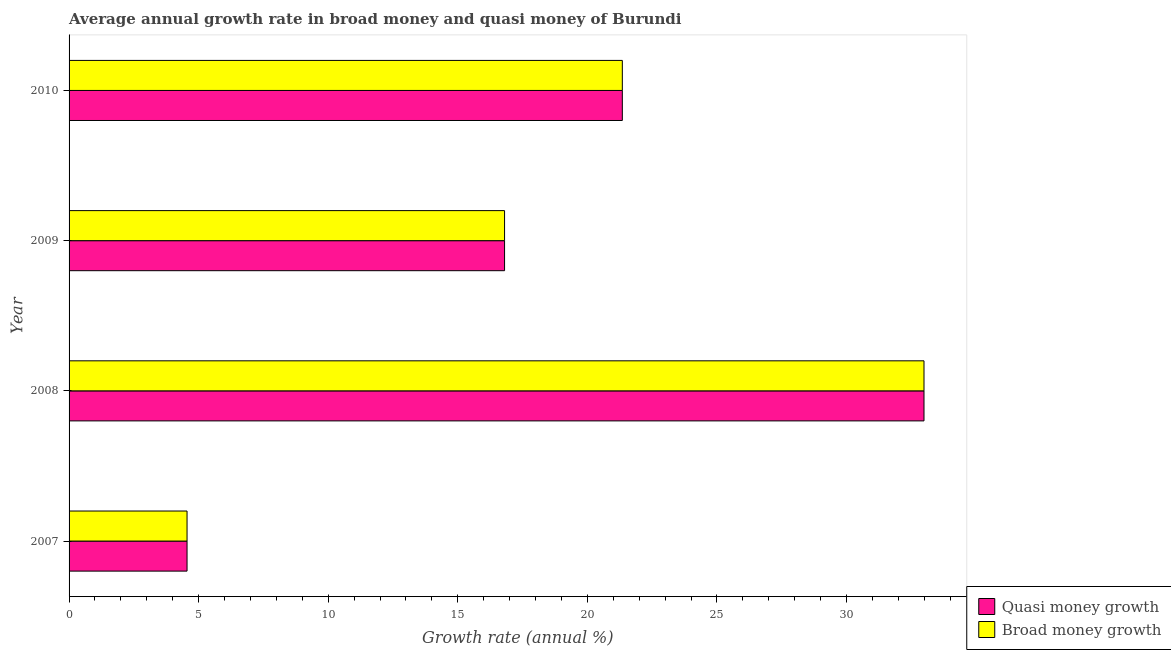How many different coloured bars are there?
Your answer should be very brief. 2. How many groups of bars are there?
Make the answer very short. 4. Are the number of bars per tick equal to the number of legend labels?
Your response must be concise. Yes. Are the number of bars on each tick of the Y-axis equal?
Your answer should be very brief. Yes. How many bars are there on the 4th tick from the top?
Ensure brevity in your answer.  2. How many bars are there on the 4th tick from the bottom?
Offer a very short reply. 2. What is the label of the 4th group of bars from the top?
Make the answer very short. 2007. What is the annual growth rate in broad money in 2008?
Ensure brevity in your answer.  32.99. Across all years, what is the maximum annual growth rate in broad money?
Give a very brief answer. 32.99. Across all years, what is the minimum annual growth rate in broad money?
Your response must be concise. 4.55. In which year was the annual growth rate in broad money maximum?
Your answer should be very brief. 2008. What is the total annual growth rate in broad money in the graph?
Offer a terse response. 75.7. What is the difference between the annual growth rate in quasi money in 2007 and that in 2008?
Ensure brevity in your answer.  -28.44. What is the difference between the annual growth rate in quasi money in 2009 and the annual growth rate in broad money in 2010?
Offer a very short reply. -4.54. What is the average annual growth rate in quasi money per year?
Provide a short and direct response. 18.93. In the year 2007, what is the difference between the annual growth rate in quasi money and annual growth rate in broad money?
Your answer should be compact. 0. What is the ratio of the annual growth rate in broad money in 2008 to that in 2009?
Provide a succinct answer. 1.96. Is the difference between the annual growth rate in quasi money in 2009 and 2010 greater than the difference between the annual growth rate in broad money in 2009 and 2010?
Make the answer very short. No. What is the difference between the highest and the second highest annual growth rate in quasi money?
Ensure brevity in your answer.  11.64. What is the difference between the highest and the lowest annual growth rate in quasi money?
Ensure brevity in your answer.  28.44. In how many years, is the annual growth rate in broad money greater than the average annual growth rate in broad money taken over all years?
Give a very brief answer. 2. Is the sum of the annual growth rate in quasi money in 2007 and 2010 greater than the maximum annual growth rate in broad money across all years?
Provide a short and direct response. No. What does the 1st bar from the top in 2007 represents?
Offer a terse response. Broad money growth. What does the 2nd bar from the bottom in 2009 represents?
Keep it short and to the point. Broad money growth. How many bars are there?
Your answer should be compact. 8. How many years are there in the graph?
Your answer should be compact. 4. Does the graph contain any zero values?
Your response must be concise. No. How many legend labels are there?
Your response must be concise. 2. How are the legend labels stacked?
Provide a short and direct response. Vertical. What is the title of the graph?
Make the answer very short. Average annual growth rate in broad money and quasi money of Burundi. Does "Primary education" appear as one of the legend labels in the graph?
Give a very brief answer. No. What is the label or title of the X-axis?
Your answer should be very brief. Growth rate (annual %). What is the label or title of the Y-axis?
Ensure brevity in your answer.  Year. What is the Growth rate (annual %) of Quasi money growth in 2007?
Your answer should be compact. 4.55. What is the Growth rate (annual %) in Broad money growth in 2007?
Give a very brief answer. 4.55. What is the Growth rate (annual %) in Quasi money growth in 2008?
Give a very brief answer. 32.99. What is the Growth rate (annual %) of Broad money growth in 2008?
Your response must be concise. 32.99. What is the Growth rate (annual %) of Quasi money growth in 2009?
Keep it short and to the point. 16.81. What is the Growth rate (annual %) of Broad money growth in 2009?
Provide a succinct answer. 16.81. What is the Growth rate (annual %) of Quasi money growth in 2010?
Provide a succinct answer. 21.35. What is the Growth rate (annual %) of Broad money growth in 2010?
Ensure brevity in your answer.  21.35. Across all years, what is the maximum Growth rate (annual %) of Quasi money growth?
Ensure brevity in your answer.  32.99. Across all years, what is the maximum Growth rate (annual %) in Broad money growth?
Your response must be concise. 32.99. Across all years, what is the minimum Growth rate (annual %) in Quasi money growth?
Give a very brief answer. 4.55. Across all years, what is the minimum Growth rate (annual %) in Broad money growth?
Keep it short and to the point. 4.55. What is the total Growth rate (annual %) of Quasi money growth in the graph?
Give a very brief answer. 75.7. What is the total Growth rate (annual %) in Broad money growth in the graph?
Offer a very short reply. 75.7. What is the difference between the Growth rate (annual %) of Quasi money growth in 2007 and that in 2008?
Make the answer very short. -28.44. What is the difference between the Growth rate (annual %) of Broad money growth in 2007 and that in 2008?
Make the answer very short. -28.44. What is the difference between the Growth rate (annual %) in Quasi money growth in 2007 and that in 2009?
Offer a very short reply. -12.25. What is the difference between the Growth rate (annual %) in Broad money growth in 2007 and that in 2009?
Your response must be concise. -12.25. What is the difference between the Growth rate (annual %) of Quasi money growth in 2007 and that in 2010?
Provide a succinct answer. -16.8. What is the difference between the Growth rate (annual %) in Broad money growth in 2007 and that in 2010?
Your answer should be very brief. -16.8. What is the difference between the Growth rate (annual %) in Quasi money growth in 2008 and that in 2009?
Provide a short and direct response. 16.19. What is the difference between the Growth rate (annual %) of Broad money growth in 2008 and that in 2009?
Offer a very short reply. 16.19. What is the difference between the Growth rate (annual %) of Quasi money growth in 2008 and that in 2010?
Your response must be concise. 11.64. What is the difference between the Growth rate (annual %) in Broad money growth in 2008 and that in 2010?
Make the answer very short. 11.64. What is the difference between the Growth rate (annual %) in Quasi money growth in 2009 and that in 2010?
Ensure brevity in your answer.  -4.54. What is the difference between the Growth rate (annual %) in Broad money growth in 2009 and that in 2010?
Your answer should be compact. -4.54. What is the difference between the Growth rate (annual %) of Quasi money growth in 2007 and the Growth rate (annual %) of Broad money growth in 2008?
Your response must be concise. -28.44. What is the difference between the Growth rate (annual %) in Quasi money growth in 2007 and the Growth rate (annual %) in Broad money growth in 2009?
Your answer should be compact. -12.25. What is the difference between the Growth rate (annual %) of Quasi money growth in 2007 and the Growth rate (annual %) of Broad money growth in 2010?
Your answer should be compact. -16.8. What is the difference between the Growth rate (annual %) of Quasi money growth in 2008 and the Growth rate (annual %) of Broad money growth in 2009?
Offer a very short reply. 16.19. What is the difference between the Growth rate (annual %) in Quasi money growth in 2008 and the Growth rate (annual %) in Broad money growth in 2010?
Provide a short and direct response. 11.64. What is the difference between the Growth rate (annual %) of Quasi money growth in 2009 and the Growth rate (annual %) of Broad money growth in 2010?
Offer a terse response. -4.54. What is the average Growth rate (annual %) in Quasi money growth per year?
Give a very brief answer. 18.92. What is the average Growth rate (annual %) in Broad money growth per year?
Provide a short and direct response. 18.92. In the year 2007, what is the difference between the Growth rate (annual %) of Quasi money growth and Growth rate (annual %) of Broad money growth?
Give a very brief answer. 0. In the year 2008, what is the difference between the Growth rate (annual %) of Quasi money growth and Growth rate (annual %) of Broad money growth?
Provide a short and direct response. 0. In the year 2009, what is the difference between the Growth rate (annual %) of Quasi money growth and Growth rate (annual %) of Broad money growth?
Ensure brevity in your answer.  0. What is the ratio of the Growth rate (annual %) of Quasi money growth in 2007 to that in 2008?
Give a very brief answer. 0.14. What is the ratio of the Growth rate (annual %) of Broad money growth in 2007 to that in 2008?
Keep it short and to the point. 0.14. What is the ratio of the Growth rate (annual %) of Quasi money growth in 2007 to that in 2009?
Ensure brevity in your answer.  0.27. What is the ratio of the Growth rate (annual %) of Broad money growth in 2007 to that in 2009?
Offer a terse response. 0.27. What is the ratio of the Growth rate (annual %) in Quasi money growth in 2007 to that in 2010?
Provide a succinct answer. 0.21. What is the ratio of the Growth rate (annual %) of Broad money growth in 2007 to that in 2010?
Make the answer very short. 0.21. What is the ratio of the Growth rate (annual %) in Quasi money growth in 2008 to that in 2009?
Give a very brief answer. 1.96. What is the ratio of the Growth rate (annual %) of Broad money growth in 2008 to that in 2009?
Your answer should be compact. 1.96. What is the ratio of the Growth rate (annual %) of Quasi money growth in 2008 to that in 2010?
Offer a terse response. 1.55. What is the ratio of the Growth rate (annual %) in Broad money growth in 2008 to that in 2010?
Your answer should be very brief. 1.55. What is the ratio of the Growth rate (annual %) of Quasi money growth in 2009 to that in 2010?
Provide a short and direct response. 0.79. What is the ratio of the Growth rate (annual %) in Broad money growth in 2009 to that in 2010?
Your answer should be compact. 0.79. What is the difference between the highest and the second highest Growth rate (annual %) in Quasi money growth?
Your response must be concise. 11.64. What is the difference between the highest and the second highest Growth rate (annual %) in Broad money growth?
Your answer should be compact. 11.64. What is the difference between the highest and the lowest Growth rate (annual %) of Quasi money growth?
Make the answer very short. 28.44. What is the difference between the highest and the lowest Growth rate (annual %) of Broad money growth?
Your answer should be compact. 28.44. 